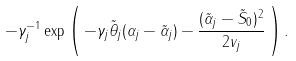Convert formula to latex. <formula><loc_0><loc_0><loc_500><loc_500>- \gamma _ { j } ^ { - 1 } \exp \left ( \, - \gamma _ { j } \tilde { \theta } _ { j } ( \alpha _ { j } - \tilde { \alpha } _ { j } ) - \frac { ( \tilde { \alpha } _ { j } - \tilde { S } _ { 0 } ) ^ { 2 } } { 2 v _ { j } } \, \right ) .</formula> 